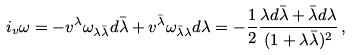<formula> <loc_0><loc_0><loc_500><loc_500>i _ { v } \omega = - v ^ { \lambda } \omega _ { \lambda \bar { \lambda } } d \bar { \lambda } + v ^ { \bar { \lambda } } \omega _ { \bar { \lambda } \lambda } d \lambda = - \frac { 1 } { 2 } \frac { \lambda d \bar { \lambda } + \bar { \lambda } d \lambda } { ( 1 + \lambda \bar { \lambda } ) ^ { 2 } } \, ,</formula> 